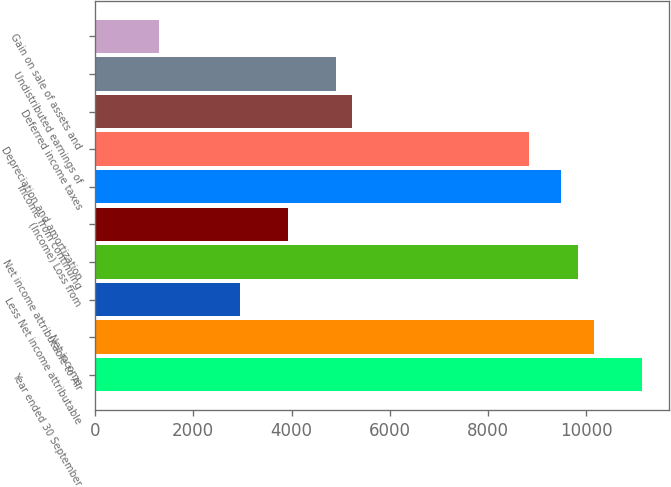Convert chart to OTSL. <chart><loc_0><loc_0><loc_500><loc_500><bar_chart><fcel>Year ended 30 September<fcel>Net income<fcel>Less Net income attributable<fcel>Net income attributable to Air<fcel>(Income) Loss from<fcel>Income from continuing<fcel>Depreciation and amortization<fcel>Deferred income taxes<fcel>Undistributed earnings of<fcel>Gain on sale of assets and<nl><fcel>11129<fcel>10147.1<fcel>2946.29<fcel>9819.8<fcel>3928.22<fcel>9492.49<fcel>8837.87<fcel>5237.46<fcel>4910.15<fcel>1309.74<nl></chart> 